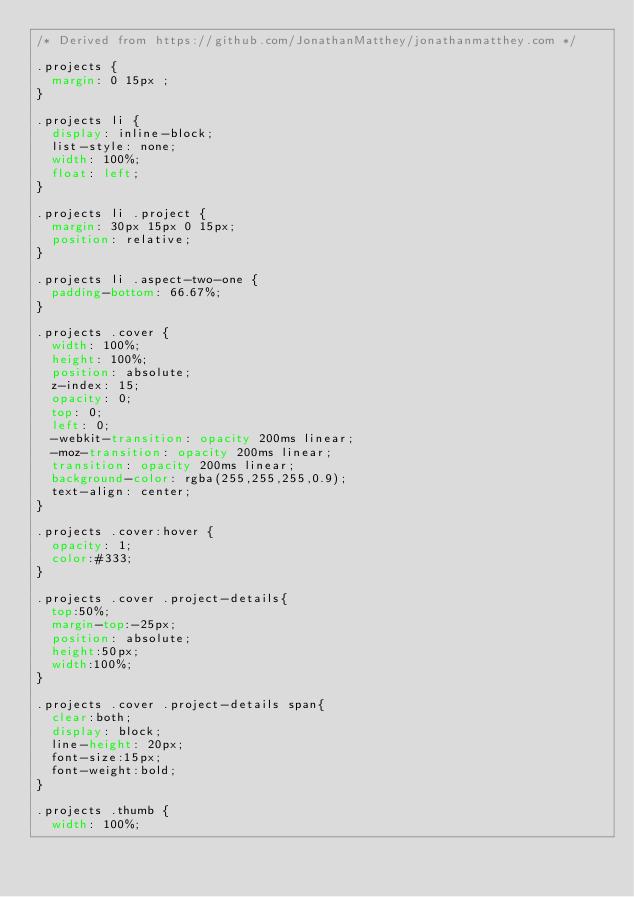<code> <loc_0><loc_0><loc_500><loc_500><_CSS_>/* Derived from https://github.com/JonathanMatthey/jonathanmatthey.com */

.projects {
  margin: 0 15px ;
}

.projects li {
  display: inline-block;
  list-style: none;
  width: 100%;
  float: left;
}

.projects li .project {
  margin: 30px 15px 0 15px;
  position: relative;
}

.projects li .aspect-two-one {
  padding-bottom: 66.67%;
}

.projects .cover {
  width: 100%;
  height: 100%;
  position: absolute;
  z-index: 15;
  opacity: 0;
  top: 0;
  left: 0;
  -webkit-transition: opacity 200ms linear;
  -moz-transition: opacity 200ms linear;
  transition: opacity 200ms linear;
  background-color: rgba(255,255,255,0.9);
  text-align: center;
}

.projects .cover:hover {
  opacity: 1;
  color:#333;
}

.projects .cover .project-details{
  top:50%;
  margin-top:-25px;
  position: absolute;
  height:50px;
  width:100%;
}

.projects .cover .project-details span{
  clear:both;
  display: block;
  line-height: 20px;
  font-size:15px;
  font-weight:bold;
}

.projects .thumb {
  width: 100%;</code> 